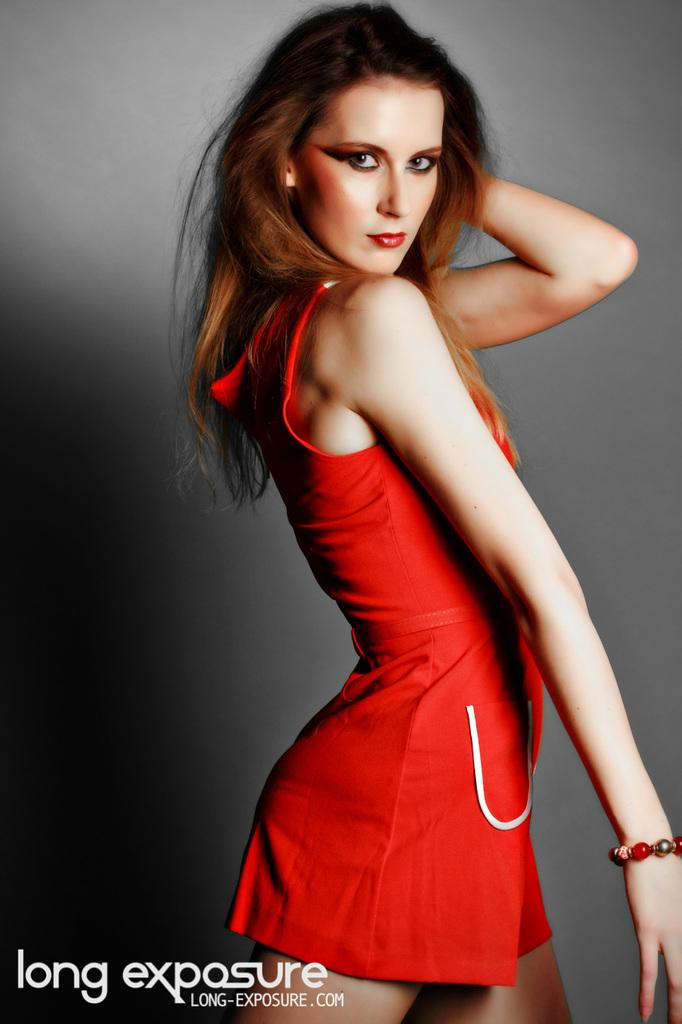Provide a one-sentence caption for the provided image. Long-exposure.com's advertisement featuring a female in a red dress. 